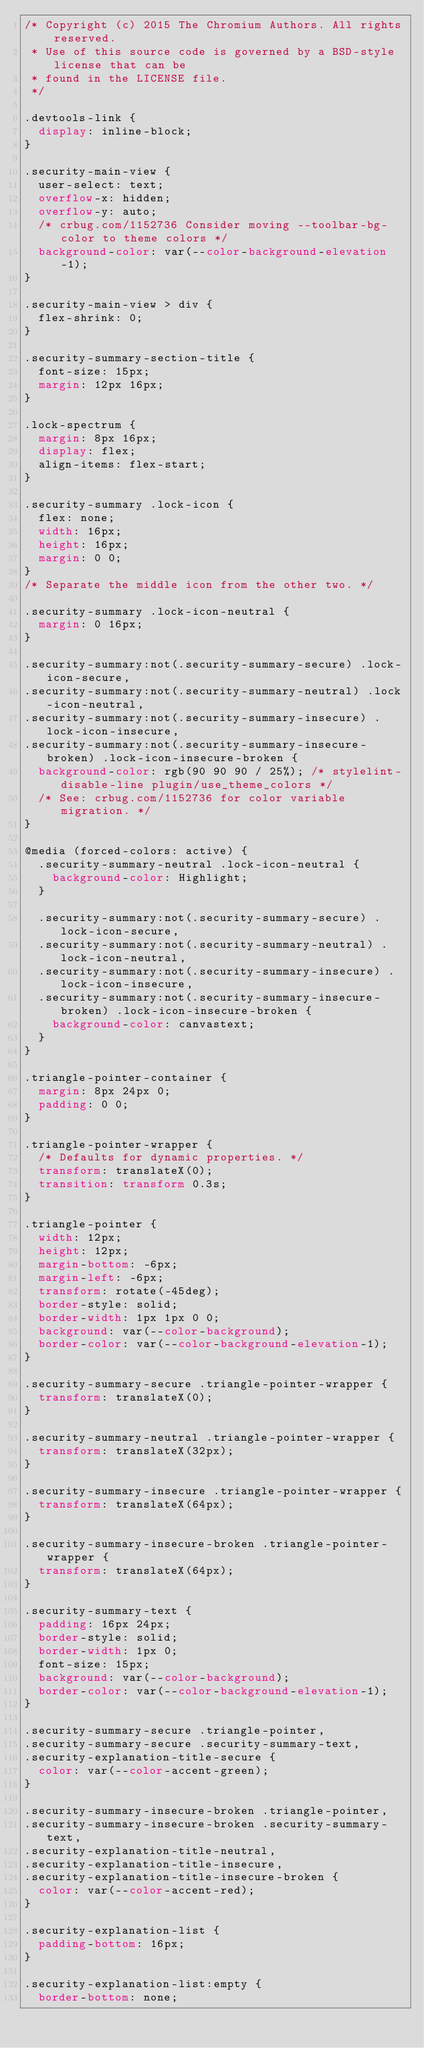<code> <loc_0><loc_0><loc_500><loc_500><_CSS_>/* Copyright (c) 2015 The Chromium Authors. All rights reserved.
 * Use of this source code is governed by a BSD-style license that can be
 * found in the LICENSE file.
 */

.devtools-link {
  display: inline-block;
}

.security-main-view {
  user-select: text;
  overflow-x: hidden;
  overflow-y: auto;
  /* crbug.com/1152736 Consider moving --toolbar-bg-color to theme colors */
  background-color: var(--color-background-elevation-1);
}

.security-main-view > div {
  flex-shrink: 0;
}

.security-summary-section-title {
  font-size: 15px;
  margin: 12px 16px;
}

.lock-spectrum {
  margin: 8px 16px;
  display: flex;
  align-items: flex-start;
}

.security-summary .lock-icon {
  flex: none;
  width: 16px;
  height: 16px;
  margin: 0 0;
}
/* Separate the middle icon from the other two. */

.security-summary .lock-icon-neutral {
  margin: 0 16px;
}

.security-summary:not(.security-summary-secure) .lock-icon-secure,
.security-summary:not(.security-summary-neutral) .lock-icon-neutral,
.security-summary:not(.security-summary-insecure) .lock-icon-insecure,
.security-summary:not(.security-summary-insecure-broken) .lock-icon-insecure-broken {
  background-color: rgb(90 90 90 / 25%); /* stylelint-disable-line plugin/use_theme_colors */
  /* See: crbug.com/1152736 for color variable migration. */
}

@media (forced-colors: active) {
  .security-summary-neutral .lock-icon-neutral {
    background-color: Highlight;
  }

  .security-summary:not(.security-summary-secure) .lock-icon-secure,
  .security-summary:not(.security-summary-neutral) .lock-icon-neutral,
  .security-summary:not(.security-summary-insecure) .lock-icon-insecure,
  .security-summary:not(.security-summary-insecure-broken) .lock-icon-insecure-broken {
    background-color: canvastext;
  }
}

.triangle-pointer-container {
  margin: 8px 24px 0;
  padding: 0 0;
}

.triangle-pointer-wrapper {
  /* Defaults for dynamic properties. */
  transform: translateX(0);
  transition: transform 0.3s;
}

.triangle-pointer {
  width: 12px;
  height: 12px;
  margin-bottom: -6px;
  margin-left: -6px;
  transform: rotate(-45deg);
  border-style: solid;
  border-width: 1px 1px 0 0;
  background: var(--color-background);
  border-color: var(--color-background-elevation-1);
}

.security-summary-secure .triangle-pointer-wrapper {
  transform: translateX(0);
}

.security-summary-neutral .triangle-pointer-wrapper {
  transform: translateX(32px);
}

.security-summary-insecure .triangle-pointer-wrapper {
  transform: translateX(64px);
}

.security-summary-insecure-broken .triangle-pointer-wrapper {
  transform: translateX(64px);
}

.security-summary-text {
  padding: 16px 24px;
  border-style: solid;
  border-width: 1px 0;
  font-size: 15px;
  background: var(--color-background);
  border-color: var(--color-background-elevation-1);
}

.security-summary-secure .triangle-pointer,
.security-summary-secure .security-summary-text,
.security-explanation-title-secure {
  color: var(--color-accent-green);
}

.security-summary-insecure-broken .triangle-pointer,
.security-summary-insecure-broken .security-summary-text,
.security-explanation-title-neutral,
.security-explanation-title-insecure,
.security-explanation-title-insecure-broken {
  color: var(--color-accent-red);
}

.security-explanation-list {
  padding-bottom: 16px;
}

.security-explanation-list:empty {
  border-bottom: none;</code> 